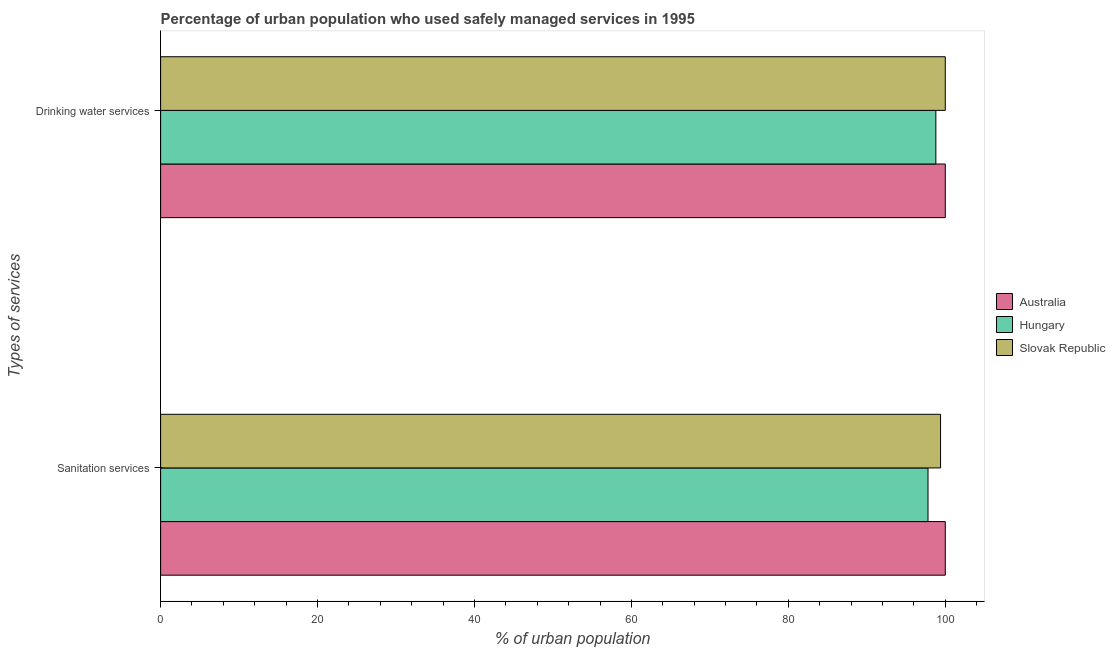Are the number of bars on each tick of the Y-axis equal?
Your answer should be compact. Yes. How many bars are there on the 2nd tick from the bottom?
Provide a succinct answer. 3. What is the label of the 1st group of bars from the top?
Offer a terse response. Drinking water services. What is the percentage of urban population who used sanitation services in Hungary?
Offer a terse response. 97.8. Across all countries, what is the maximum percentage of urban population who used sanitation services?
Make the answer very short. 100. Across all countries, what is the minimum percentage of urban population who used sanitation services?
Make the answer very short. 97.8. In which country was the percentage of urban population who used drinking water services maximum?
Give a very brief answer. Australia. In which country was the percentage of urban population who used sanitation services minimum?
Your answer should be very brief. Hungary. What is the total percentage of urban population who used sanitation services in the graph?
Keep it short and to the point. 297.2. What is the difference between the percentage of urban population who used drinking water services in Hungary and that in Australia?
Make the answer very short. -1.2. What is the difference between the percentage of urban population who used sanitation services in Hungary and the percentage of urban population who used drinking water services in Slovak Republic?
Keep it short and to the point. -2.2. What is the average percentage of urban population who used sanitation services per country?
Provide a succinct answer. 99.07. What is the difference between the percentage of urban population who used sanitation services and percentage of urban population who used drinking water services in Hungary?
Offer a terse response. -1. What is the ratio of the percentage of urban population who used sanitation services in Hungary to that in Slovak Republic?
Make the answer very short. 0.98. Is the percentage of urban population who used drinking water services in Australia less than that in Slovak Republic?
Offer a very short reply. No. In how many countries, is the percentage of urban population who used drinking water services greater than the average percentage of urban population who used drinking water services taken over all countries?
Your response must be concise. 2. What does the 3rd bar from the top in Sanitation services represents?
Your response must be concise. Australia. What does the 2nd bar from the bottom in Sanitation services represents?
Provide a succinct answer. Hungary. How many bars are there?
Give a very brief answer. 6. Are all the bars in the graph horizontal?
Your answer should be compact. Yes. How many countries are there in the graph?
Ensure brevity in your answer.  3. Does the graph contain grids?
Keep it short and to the point. No. How many legend labels are there?
Keep it short and to the point. 3. What is the title of the graph?
Offer a terse response. Percentage of urban population who used safely managed services in 1995. Does "Papua New Guinea" appear as one of the legend labels in the graph?
Ensure brevity in your answer.  No. What is the label or title of the X-axis?
Offer a very short reply. % of urban population. What is the label or title of the Y-axis?
Keep it short and to the point. Types of services. What is the % of urban population of Hungary in Sanitation services?
Offer a terse response. 97.8. What is the % of urban population of Slovak Republic in Sanitation services?
Ensure brevity in your answer.  99.4. What is the % of urban population of Hungary in Drinking water services?
Keep it short and to the point. 98.8. Across all Types of services, what is the maximum % of urban population of Hungary?
Your response must be concise. 98.8. Across all Types of services, what is the minimum % of urban population in Australia?
Provide a succinct answer. 100. Across all Types of services, what is the minimum % of urban population of Hungary?
Provide a succinct answer. 97.8. Across all Types of services, what is the minimum % of urban population in Slovak Republic?
Give a very brief answer. 99.4. What is the total % of urban population of Hungary in the graph?
Your answer should be very brief. 196.6. What is the total % of urban population of Slovak Republic in the graph?
Provide a succinct answer. 199.4. What is the difference between the % of urban population in Hungary in Sanitation services and that in Drinking water services?
Your answer should be compact. -1. What is the difference between the % of urban population of Slovak Republic in Sanitation services and that in Drinking water services?
Ensure brevity in your answer.  -0.6. What is the difference between the % of urban population of Australia in Sanitation services and the % of urban population of Hungary in Drinking water services?
Make the answer very short. 1.2. What is the difference between the % of urban population in Hungary in Sanitation services and the % of urban population in Slovak Republic in Drinking water services?
Provide a succinct answer. -2.2. What is the average % of urban population in Australia per Types of services?
Make the answer very short. 100. What is the average % of urban population in Hungary per Types of services?
Your response must be concise. 98.3. What is the average % of urban population in Slovak Republic per Types of services?
Offer a very short reply. 99.7. What is the difference between the % of urban population in Australia and % of urban population in Hungary in Sanitation services?
Offer a terse response. 2.2. What is the difference between the % of urban population in Australia and % of urban population in Slovak Republic in Drinking water services?
Your answer should be compact. 0. What is the difference between the % of urban population in Hungary and % of urban population in Slovak Republic in Drinking water services?
Your answer should be compact. -1.2. What is the ratio of the % of urban population in Australia in Sanitation services to that in Drinking water services?
Ensure brevity in your answer.  1. What is the difference between the highest and the second highest % of urban population in Australia?
Your answer should be compact. 0. What is the difference between the highest and the second highest % of urban population in Hungary?
Provide a succinct answer. 1. What is the difference between the highest and the lowest % of urban population of Hungary?
Your answer should be compact. 1. 